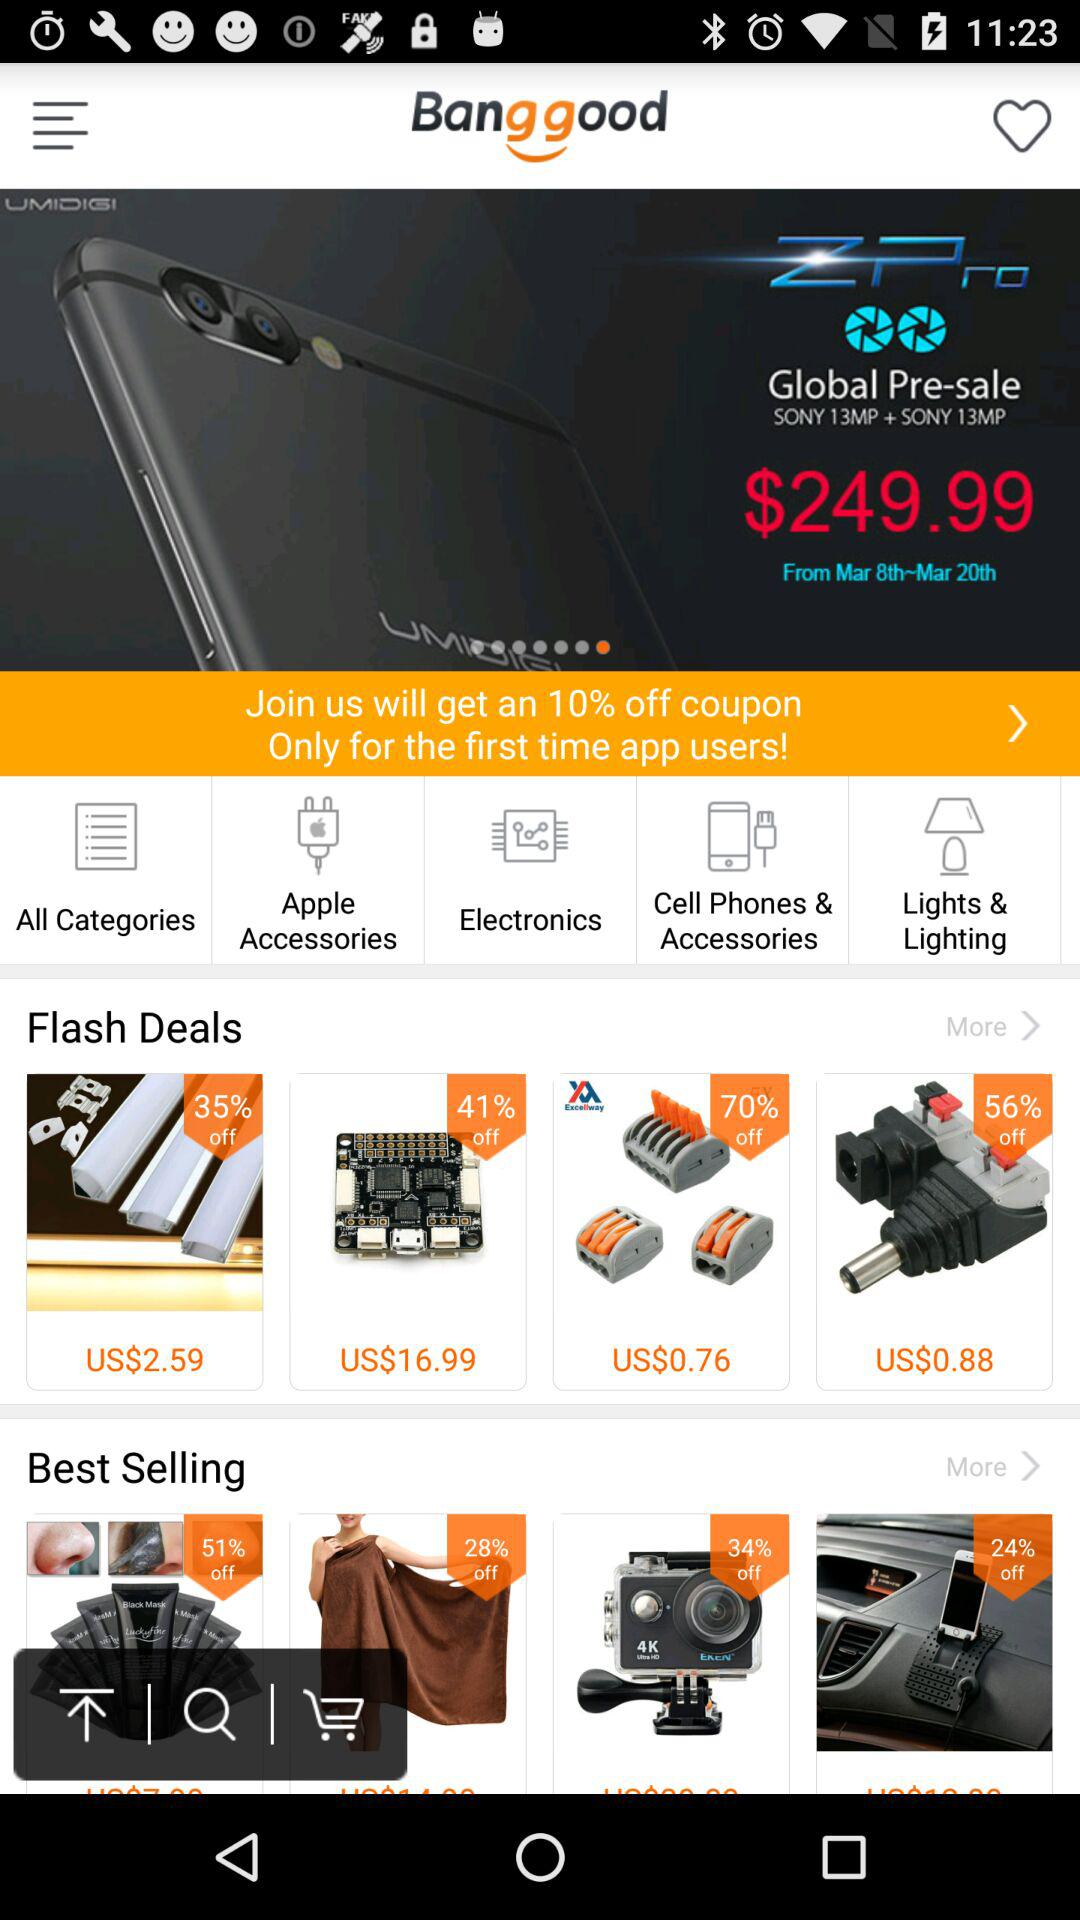What is the version of this application?
When the provided information is insufficient, respond with <no answer>. <no answer> 